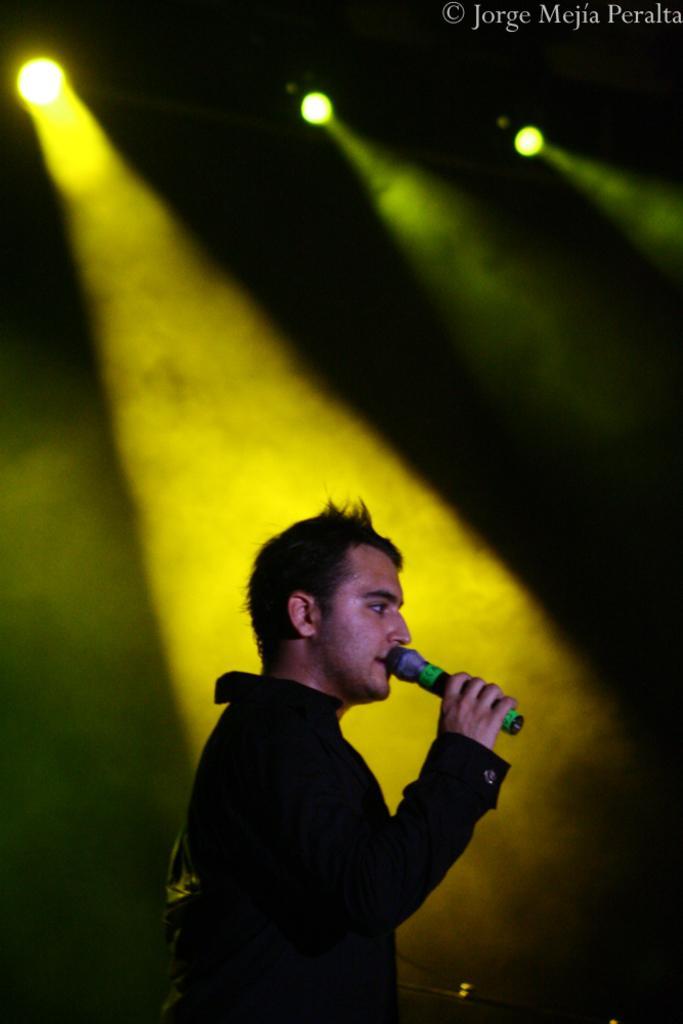In one or two sentences, can you explain what this image depicts? In the image there is a man standing and holding a mic in his hand. Behind him there are lights. In the top right corner of the image there is a name. 